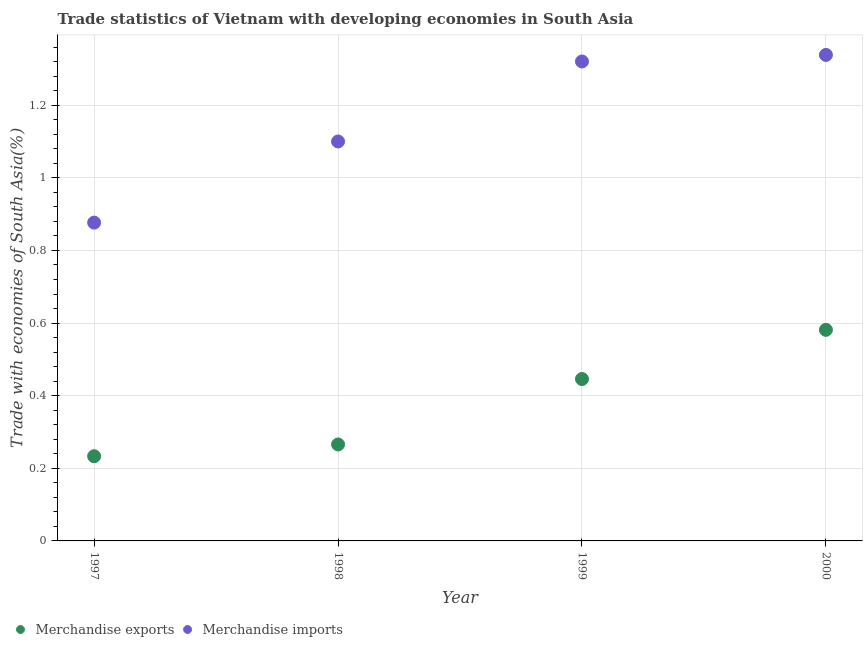How many different coloured dotlines are there?
Provide a short and direct response. 2. What is the merchandise exports in 1997?
Ensure brevity in your answer.  0.23. Across all years, what is the maximum merchandise exports?
Offer a very short reply. 0.58. Across all years, what is the minimum merchandise imports?
Provide a short and direct response. 0.88. In which year was the merchandise exports maximum?
Ensure brevity in your answer.  2000. In which year was the merchandise exports minimum?
Offer a very short reply. 1997. What is the total merchandise exports in the graph?
Your answer should be very brief. 1.53. What is the difference between the merchandise imports in 1998 and that in 1999?
Your answer should be very brief. -0.22. What is the difference between the merchandise imports in 1997 and the merchandise exports in 2000?
Offer a terse response. 0.3. What is the average merchandise exports per year?
Your response must be concise. 0.38. In the year 2000, what is the difference between the merchandise exports and merchandise imports?
Your answer should be very brief. -0.76. In how many years, is the merchandise imports greater than 0.24000000000000002 %?
Provide a short and direct response. 4. What is the ratio of the merchandise exports in 1998 to that in 1999?
Your answer should be very brief. 0.6. Is the merchandise imports in 1997 less than that in 2000?
Ensure brevity in your answer.  Yes. Is the difference between the merchandise exports in 1997 and 1998 greater than the difference between the merchandise imports in 1997 and 1998?
Your response must be concise. Yes. What is the difference between the highest and the second highest merchandise imports?
Your response must be concise. 0.02. What is the difference between the highest and the lowest merchandise imports?
Your answer should be very brief. 0.46. Is the sum of the merchandise imports in 1998 and 1999 greater than the maximum merchandise exports across all years?
Your answer should be compact. Yes. Does the merchandise exports monotonically increase over the years?
Give a very brief answer. Yes. Is the merchandise imports strictly less than the merchandise exports over the years?
Provide a short and direct response. No. Does the graph contain grids?
Your answer should be very brief. Yes. Where does the legend appear in the graph?
Provide a succinct answer. Bottom left. What is the title of the graph?
Ensure brevity in your answer.  Trade statistics of Vietnam with developing economies in South Asia. What is the label or title of the Y-axis?
Offer a terse response. Trade with economies of South Asia(%). What is the Trade with economies of South Asia(%) of Merchandise exports in 1997?
Keep it short and to the point. 0.23. What is the Trade with economies of South Asia(%) of Merchandise imports in 1997?
Give a very brief answer. 0.88. What is the Trade with economies of South Asia(%) in Merchandise exports in 1998?
Offer a terse response. 0.27. What is the Trade with economies of South Asia(%) in Merchandise imports in 1998?
Your answer should be compact. 1.1. What is the Trade with economies of South Asia(%) in Merchandise exports in 1999?
Your answer should be very brief. 0.45. What is the Trade with economies of South Asia(%) of Merchandise imports in 1999?
Provide a succinct answer. 1.32. What is the Trade with economies of South Asia(%) in Merchandise exports in 2000?
Provide a short and direct response. 0.58. What is the Trade with economies of South Asia(%) of Merchandise imports in 2000?
Provide a succinct answer. 1.34. Across all years, what is the maximum Trade with economies of South Asia(%) in Merchandise exports?
Give a very brief answer. 0.58. Across all years, what is the maximum Trade with economies of South Asia(%) in Merchandise imports?
Offer a very short reply. 1.34. Across all years, what is the minimum Trade with economies of South Asia(%) of Merchandise exports?
Make the answer very short. 0.23. Across all years, what is the minimum Trade with economies of South Asia(%) in Merchandise imports?
Keep it short and to the point. 0.88. What is the total Trade with economies of South Asia(%) in Merchandise exports in the graph?
Offer a very short reply. 1.53. What is the total Trade with economies of South Asia(%) of Merchandise imports in the graph?
Keep it short and to the point. 4.64. What is the difference between the Trade with economies of South Asia(%) of Merchandise exports in 1997 and that in 1998?
Keep it short and to the point. -0.03. What is the difference between the Trade with economies of South Asia(%) in Merchandise imports in 1997 and that in 1998?
Your response must be concise. -0.22. What is the difference between the Trade with economies of South Asia(%) in Merchandise exports in 1997 and that in 1999?
Offer a very short reply. -0.21. What is the difference between the Trade with economies of South Asia(%) in Merchandise imports in 1997 and that in 1999?
Make the answer very short. -0.44. What is the difference between the Trade with economies of South Asia(%) in Merchandise exports in 1997 and that in 2000?
Provide a succinct answer. -0.35. What is the difference between the Trade with economies of South Asia(%) of Merchandise imports in 1997 and that in 2000?
Your response must be concise. -0.46. What is the difference between the Trade with economies of South Asia(%) of Merchandise exports in 1998 and that in 1999?
Your answer should be very brief. -0.18. What is the difference between the Trade with economies of South Asia(%) of Merchandise imports in 1998 and that in 1999?
Your answer should be very brief. -0.22. What is the difference between the Trade with economies of South Asia(%) of Merchandise exports in 1998 and that in 2000?
Offer a very short reply. -0.32. What is the difference between the Trade with economies of South Asia(%) of Merchandise imports in 1998 and that in 2000?
Keep it short and to the point. -0.24. What is the difference between the Trade with economies of South Asia(%) of Merchandise exports in 1999 and that in 2000?
Provide a succinct answer. -0.14. What is the difference between the Trade with economies of South Asia(%) of Merchandise imports in 1999 and that in 2000?
Offer a terse response. -0.02. What is the difference between the Trade with economies of South Asia(%) of Merchandise exports in 1997 and the Trade with economies of South Asia(%) of Merchandise imports in 1998?
Give a very brief answer. -0.87. What is the difference between the Trade with economies of South Asia(%) of Merchandise exports in 1997 and the Trade with economies of South Asia(%) of Merchandise imports in 1999?
Offer a very short reply. -1.09. What is the difference between the Trade with economies of South Asia(%) in Merchandise exports in 1997 and the Trade with economies of South Asia(%) in Merchandise imports in 2000?
Ensure brevity in your answer.  -1.11. What is the difference between the Trade with economies of South Asia(%) of Merchandise exports in 1998 and the Trade with economies of South Asia(%) of Merchandise imports in 1999?
Your answer should be compact. -1.05. What is the difference between the Trade with economies of South Asia(%) in Merchandise exports in 1998 and the Trade with economies of South Asia(%) in Merchandise imports in 2000?
Provide a succinct answer. -1.07. What is the difference between the Trade with economies of South Asia(%) of Merchandise exports in 1999 and the Trade with economies of South Asia(%) of Merchandise imports in 2000?
Offer a terse response. -0.89. What is the average Trade with economies of South Asia(%) of Merchandise exports per year?
Make the answer very short. 0.38. What is the average Trade with economies of South Asia(%) of Merchandise imports per year?
Your answer should be compact. 1.16. In the year 1997, what is the difference between the Trade with economies of South Asia(%) in Merchandise exports and Trade with economies of South Asia(%) in Merchandise imports?
Ensure brevity in your answer.  -0.64. In the year 1998, what is the difference between the Trade with economies of South Asia(%) of Merchandise exports and Trade with economies of South Asia(%) of Merchandise imports?
Provide a succinct answer. -0.83. In the year 1999, what is the difference between the Trade with economies of South Asia(%) in Merchandise exports and Trade with economies of South Asia(%) in Merchandise imports?
Provide a succinct answer. -0.87. In the year 2000, what is the difference between the Trade with economies of South Asia(%) of Merchandise exports and Trade with economies of South Asia(%) of Merchandise imports?
Your answer should be compact. -0.76. What is the ratio of the Trade with economies of South Asia(%) of Merchandise exports in 1997 to that in 1998?
Provide a succinct answer. 0.88. What is the ratio of the Trade with economies of South Asia(%) of Merchandise imports in 1997 to that in 1998?
Your answer should be compact. 0.8. What is the ratio of the Trade with economies of South Asia(%) in Merchandise exports in 1997 to that in 1999?
Keep it short and to the point. 0.52. What is the ratio of the Trade with economies of South Asia(%) in Merchandise imports in 1997 to that in 1999?
Your answer should be very brief. 0.66. What is the ratio of the Trade with economies of South Asia(%) of Merchandise exports in 1997 to that in 2000?
Offer a terse response. 0.4. What is the ratio of the Trade with economies of South Asia(%) in Merchandise imports in 1997 to that in 2000?
Your answer should be compact. 0.66. What is the ratio of the Trade with economies of South Asia(%) in Merchandise exports in 1998 to that in 1999?
Offer a terse response. 0.6. What is the ratio of the Trade with economies of South Asia(%) in Merchandise imports in 1998 to that in 1999?
Keep it short and to the point. 0.83. What is the ratio of the Trade with economies of South Asia(%) in Merchandise exports in 1998 to that in 2000?
Your answer should be compact. 0.46. What is the ratio of the Trade with economies of South Asia(%) of Merchandise imports in 1998 to that in 2000?
Your response must be concise. 0.82. What is the ratio of the Trade with economies of South Asia(%) of Merchandise exports in 1999 to that in 2000?
Provide a short and direct response. 0.77. What is the ratio of the Trade with economies of South Asia(%) of Merchandise imports in 1999 to that in 2000?
Keep it short and to the point. 0.99. What is the difference between the highest and the second highest Trade with economies of South Asia(%) of Merchandise exports?
Offer a terse response. 0.14. What is the difference between the highest and the second highest Trade with economies of South Asia(%) of Merchandise imports?
Your answer should be very brief. 0.02. What is the difference between the highest and the lowest Trade with economies of South Asia(%) in Merchandise exports?
Ensure brevity in your answer.  0.35. What is the difference between the highest and the lowest Trade with economies of South Asia(%) in Merchandise imports?
Keep it short and to the point. 0.46. 